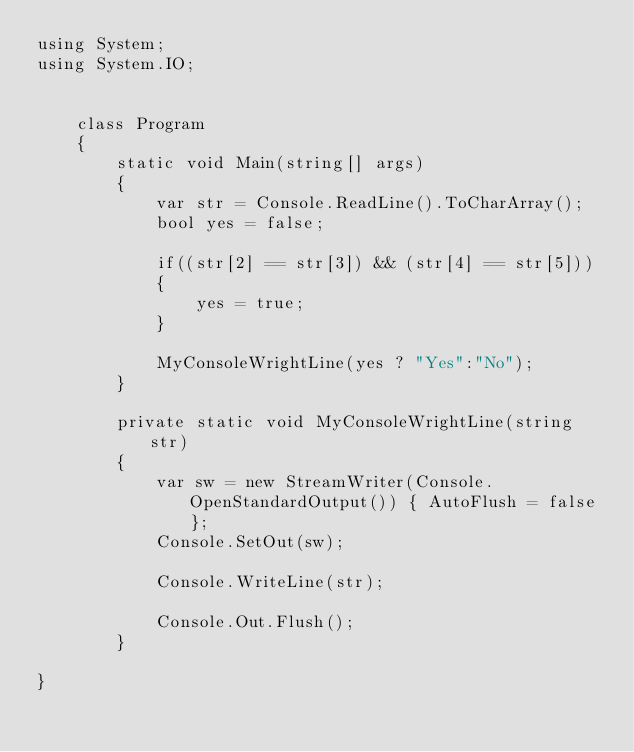Convert code to text. <code><loc_0><loc_0><loc_500><loc_500><_C#_>using System;
using System.IO;


    class Program
    {
        static void Main(string[] args)
        {
            var str = Console.ReadLine().ToCharArray();
            bool yes = false;

            if((str[2] == str[3]) && (str[4] == str[5]))
            {
                yes = true;
            }

            MyConsoleWrightLine(yes ? "Yes":"No");
        }

        private static void MyConsoleWrightLine(string str)
        {
            var sw = new StreamWriter(Console.OpenStandardOutput()) { AutoFlush = false };
            Console.SetOut(sw);

            Console.WriteLine(str);

            Console.Out.Flush();
        }

}
</code> 